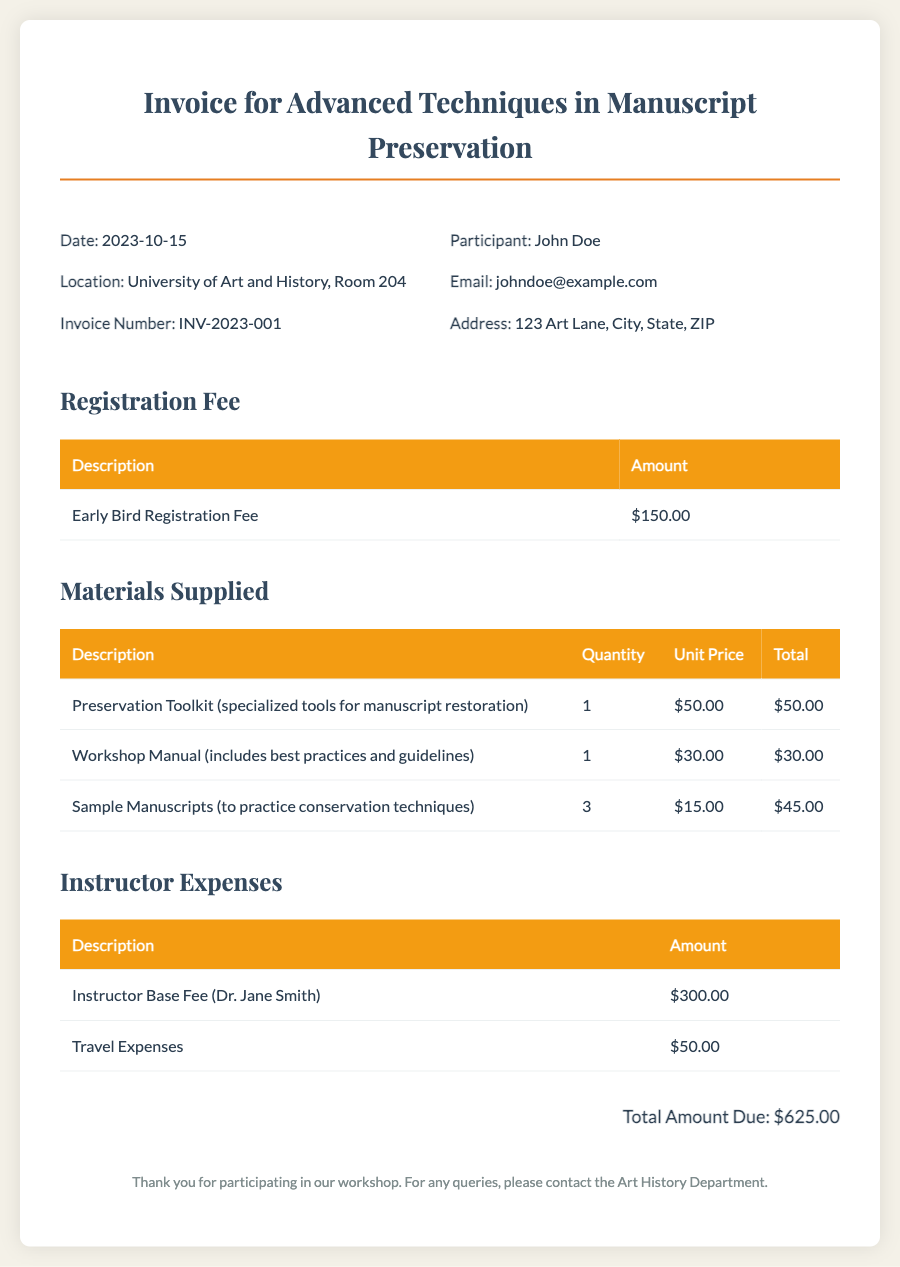What is the date of the workshop? The date of the workshop is mentioned in the header of the document as 2023-10-15.
Answer: 2023-10-15 What is the registration fee? The registration fee is listed in the section titled "Registration Fee" as $150.00.
Answer: $150.00 Who is the instructor for the workshop? The instructor is mentioned in the "Instructor Expenses" section as Dr. Jane Smith.
Answer: Dr. Jane Smith How many sample manuscripts were supplied? The materials supplied include a row that states there were 3 sample manuscripts provided for practice.
Answer: 3 What is the total amount due? The total amount due is summed up at the end of the invoice, which is $625.00.
Answer: $625.00 What is the location of the workshop? The location is specified in the header of the document as University of Art and History, Room 204.
Answer: University of Art and History, Room 204 What is included in the preservation toolkit? The toolkit is described as "specialized tools for manuscript restoration" in the materials table.
Answer: specialized tools for manuscript restoration What are the travel expenses for the instructor? The travel expenses for Dr. Jane Smith are listed under "Instructor Expenses" and amount to $50.00.
Answer: $50.00 What was the quantity of the workshop manual supplied? The workshop manual's quantity is listed in the materials table as 1.
Answer: 1 